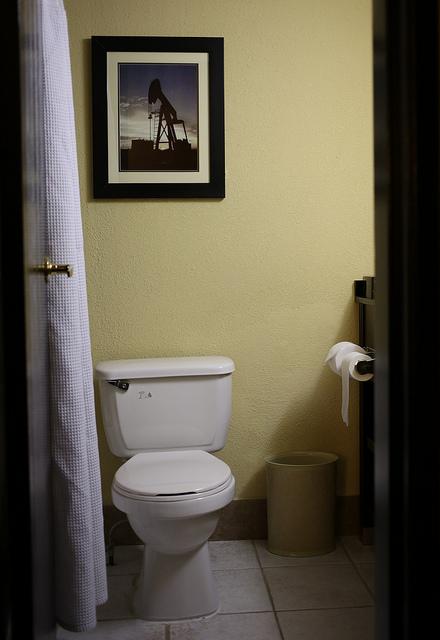What room is this?
Quick response, please. Bathroom. Is there a trash can?
Give a very brief answer. Yes. What color is the trash can?
Answer briefly. Beige. Is there a bidet in the picture?
Write a very short answer. No. What color is the wall behind the toilet?
Concise answer only. Yellow. Is there toilet paper left?
Give a very brief answer. Yes. Is this photo outdoors?
Quick response, please. No. Is this in working condition?
Answer briefly. Yes. Is there tissue on the roll?
Answer briefly. Yes. Is there any decorations in this room?
Quick response, please. Yes. Which color is the toilet seat?
Keep it brief. White. Is the toilet seat up?
Give a very brief answer. No. Is there a full roll of toilet paper?
Short answer required. Yes. What is hanging on the door?
Answer briefly. Towel. What is on the wall behind the toilet?
Keep it brief. Picture. How many rolls of Toilet tissue do you see?
Answer briefly. 2. 